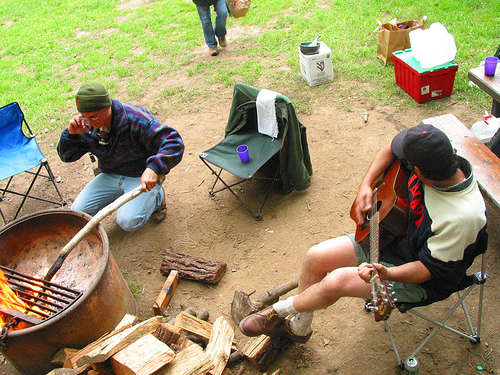<image>
Is there a cup on the chair? Yes. Looking at the image, I can see the cup is positioned on top of the chair, with the chair providing support. Is there a cup under the chair? No. The cup is not positioned under the chair. The vertical relationship between these objects is different. Is the wood to the left of the man? Yes. From this viewpoint, the wood is positioned to the left side relative to the man. 